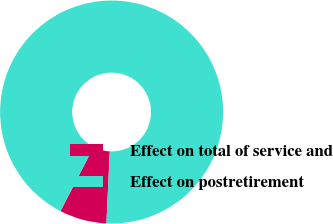<chart> <loc_0><loc_0><loc_500><loc_500><pie_chart><fcel>Effect on total of service and<fcel>Effect on postretirement<nl><fcel>6.84%<fcel>93.16%<nl></chart> 